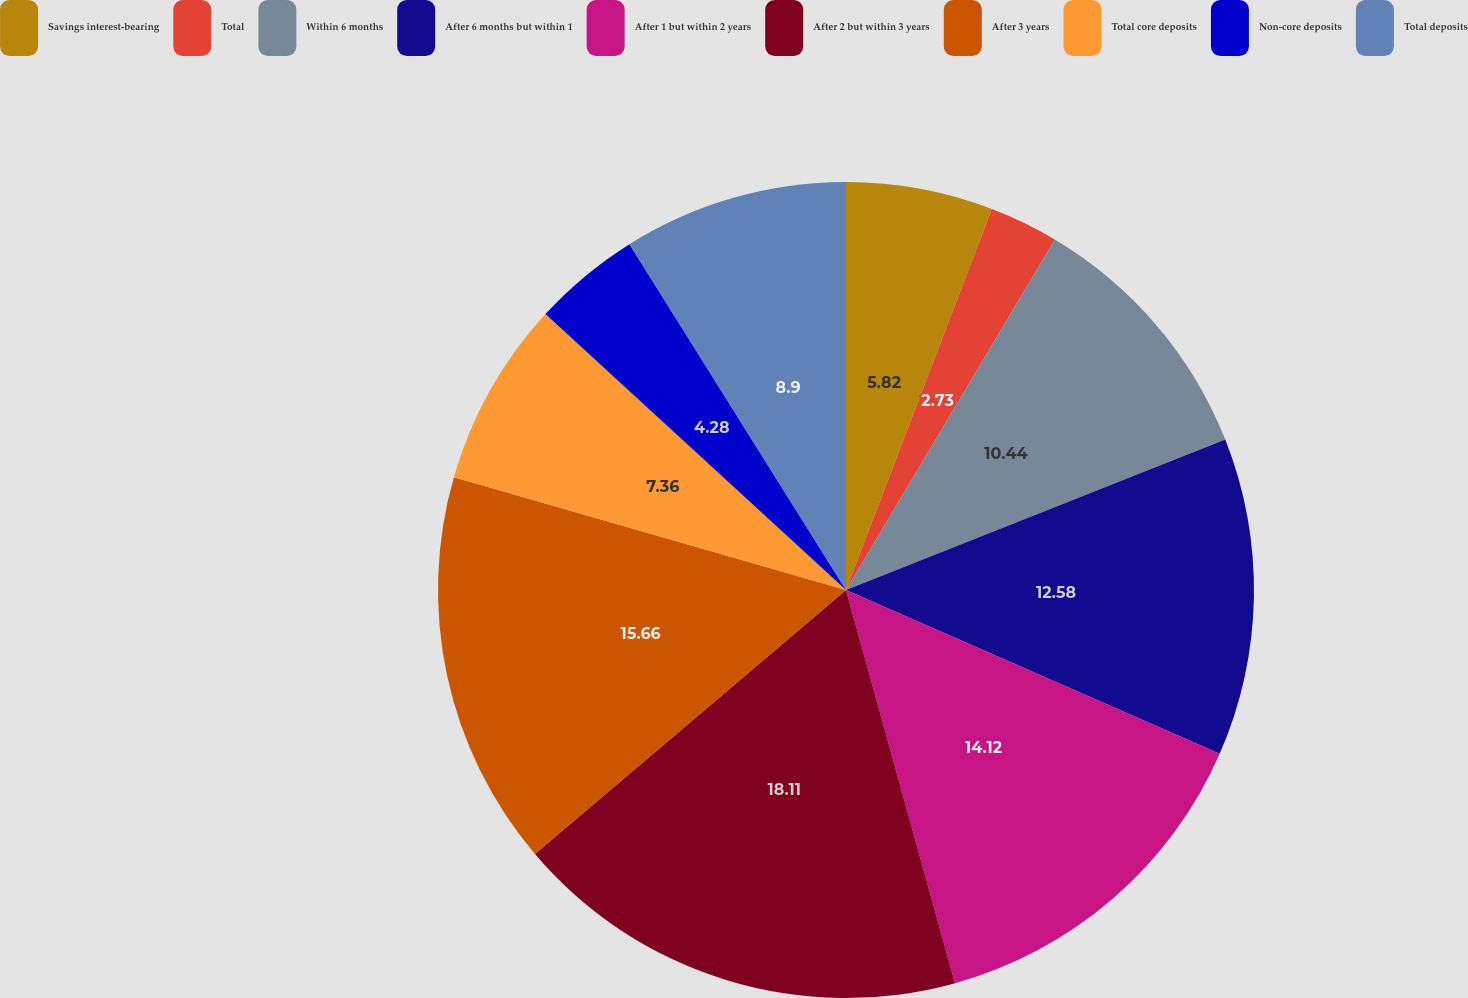Convert chart to OTSL. <chart><loc_0><loc_0><loc_500><loc_500><pie_chart><fcel>Savings interest-bearing<fcel>Total<fcel>Within 6 months<fcel>After 6 months but within 1<fcel>After 1 but within 2 years<fcel>After 2 but within 3 years<fcel>After 3 years<fcel>Total core deposits<fcel>Non-core deposits<fcel>Total deposits<nl><fcel>5.82%<fcel>2.73%<fcel>10.44%<fcel>12.58%<fcel>14.12%<fcel>18.1%<fcel>15.66%<fcel>7.36%<fcel>4.28%<fcel>8.9%<nl></chart> 